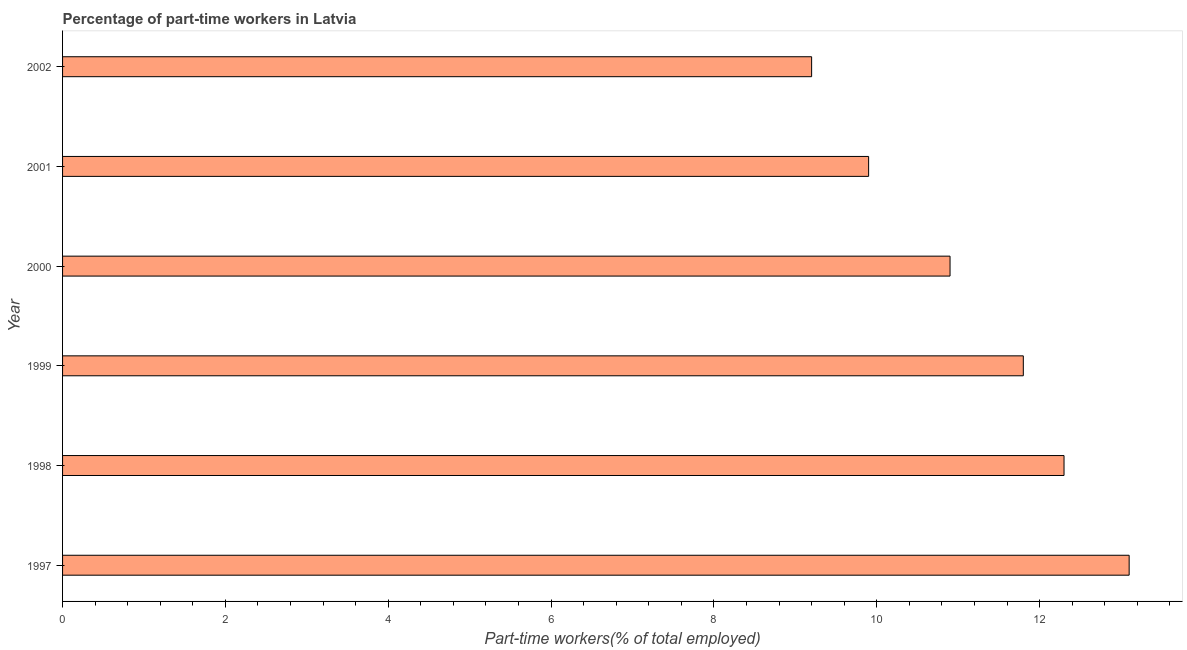Does the graph contain any zero values?
Your answer should be compact. No. Does the graph contain grids?
Make the answer very short. No. What is the title of the graph?
Your answer should be very brief. Percentage of part-time workers in Latvia. What is the label or title of the X-axis?
Your answer should be compact. Part-time workers(% of total employed). What is the percentage of part-time workers in 2001?
Provide a succinct answer. 9.9. Across all years, what is the maximum percentage of part-time workers?
Offer a terse response. 13.1. Across all years, what is the minimum percentage of part-time workers?
Offer a terse response. 9.2. What is the sum of the percentage of part-time workers?
Make the answer very short. 67.2. What is the difference between the percentage of part-time workers in 1997 and 2000?
Offer a terse response. 2.2. What is the average percentage of part-time workers per year?
Make the answer very short. 11.2. What is the median percentage of part-time workers?
Provide a short and direct response. 11.35. Do a majority of the years between 2002 and 2000 (inclusive) have percentage of part-time workers greater than 4.4 %?
Ensure brevity in your answer.  Yes. What is the ratio of the percentage of part-time workers in 1998 to that in 1999?
Provide a succinct answer. 1.04. Is the difference between the percentage of part-time workers in 1997 and 1999 greater than the difference between any two years?
Ensure brevity in your answer.  No. What is the difference between the highest and the lowest percentage of part-time workers?
Make the answer very short. 3.9. How many bars are there?
Your answer should be compact. 6. Are all the bars in the graph horizontal?
Offer a terse response. Yes. Are the values on the major ticks of X-axis written in scientific E-notation?
Make the answer very short. No. What is the Part-time workers(% of total employed) of 1997?
Give a very brief answer. 13.1. What is the Part-time workers(% of total employed) of 1998?
Your answer should be compact. 12.3. What is the Part-time workers(% of total employed) in 1999?
Offer a terse response. 11.8. What is the Part-time workers(% of total employed) in 2000?
Offer a very short reply. 10.9. What is the Part-time workers(% of total employed) of 2001?
Keep it short and to the point. 9.9. What is the Part-time workers(% of total employed) of 2002?
Your response must be concise. 9.2. What is the difference between the Part-time workers(% of total employed) in 1997 and 1998?
Give a very brief answer. 0.8. What is the difference between the Part-time workers(% of total employed) in 1997 and 1999?
Keep it short and to the point. 1.3. What is the difference between the Part-time workers(% of total employed) in 1997 and 2002?
Offer a very short reply. 3.9. What is the difference between the Part-time workers(% of total employed) in 1998 and 2002?
Your response must be concise. 3.1. What is the difference between the Part-time workers(% of total employed) in 1999 and 2001?
Ensure brevity in your answer.  1.9. What is the difference between the Part-time workers(% of total employed) in 1999 and 2002?
Provide a short and direct response. 2.6. What is the difference between the Part-time workers(% of total employed) in 2000 and 2001?
Your answer should be very brief. 1. What is the difference between the Part-time workers(% of total employed) in 2000 and 2002?
Ensure brevity in your answer.  1.7. What is the ratio of the Part-time workers(% of total employed) in 1997 to that in 1998?
Offer a very short reply. 1.06. What is the ratio of the Part-time workers(% of total employed) in 1997 to that in 1999?
Your answer should be compact. 1.11. What is the ratio of the Part-time workers(% of total employed) in 1997 to that in 2000?
Provide a short and direct response. 1.2. What is the ratio of the Part-time workers(% of total employed) in 1997 to that in 2001?
Your answer should be very brief. 1.32. What is the ratio of the Part-time workers(% of total employed) in 1997 to that in 2002?
Your answer should be very brief. 1.42. What is the ratio of the Part-time workers(% of total employed) in 1998 to that in 1999?
Your response must be concise. 1.04. What is the ratio of the Part-time workers(% of total employed) in 1998 to that in 2000?
Offer a very short reply. 1.13. What is the ratio of the Part-time workers(% of total employed) in 1998 to that in 2001?
Ensure brevity in your answer.  1.24. What is the ratio of the Part-time workers(% of total employed) in 1998 to that in 2002?
Your answer should be very brief. 1.34. What is the ratio of the Part-time workers(% of total employed) in 1999 to that in 2000?
Your answer should be very brief. 1.08. What is the ratio of the Part-time workers(% of total employed) in 1999 to that in 2001?
Your response must be concise. 1.19. What is the ratio of the Part-time workers(% of total employed) in 1999 to that in 2002?
Make the answer very short. 1.28. What is the ratio of the Part-time workers(% of total employed) in 2000 to that in 2001?
Keep it short and to the point. 1.1. What is the ratio of the Part-time workers(% of total employed) in 2000 to that in 2002?
Ensure brevity in your answer.  1.19. What is the ratio of the Part-time workers(% of total employed) in 2001 to that in 2002?
Give a very brief answer. 1.08. 